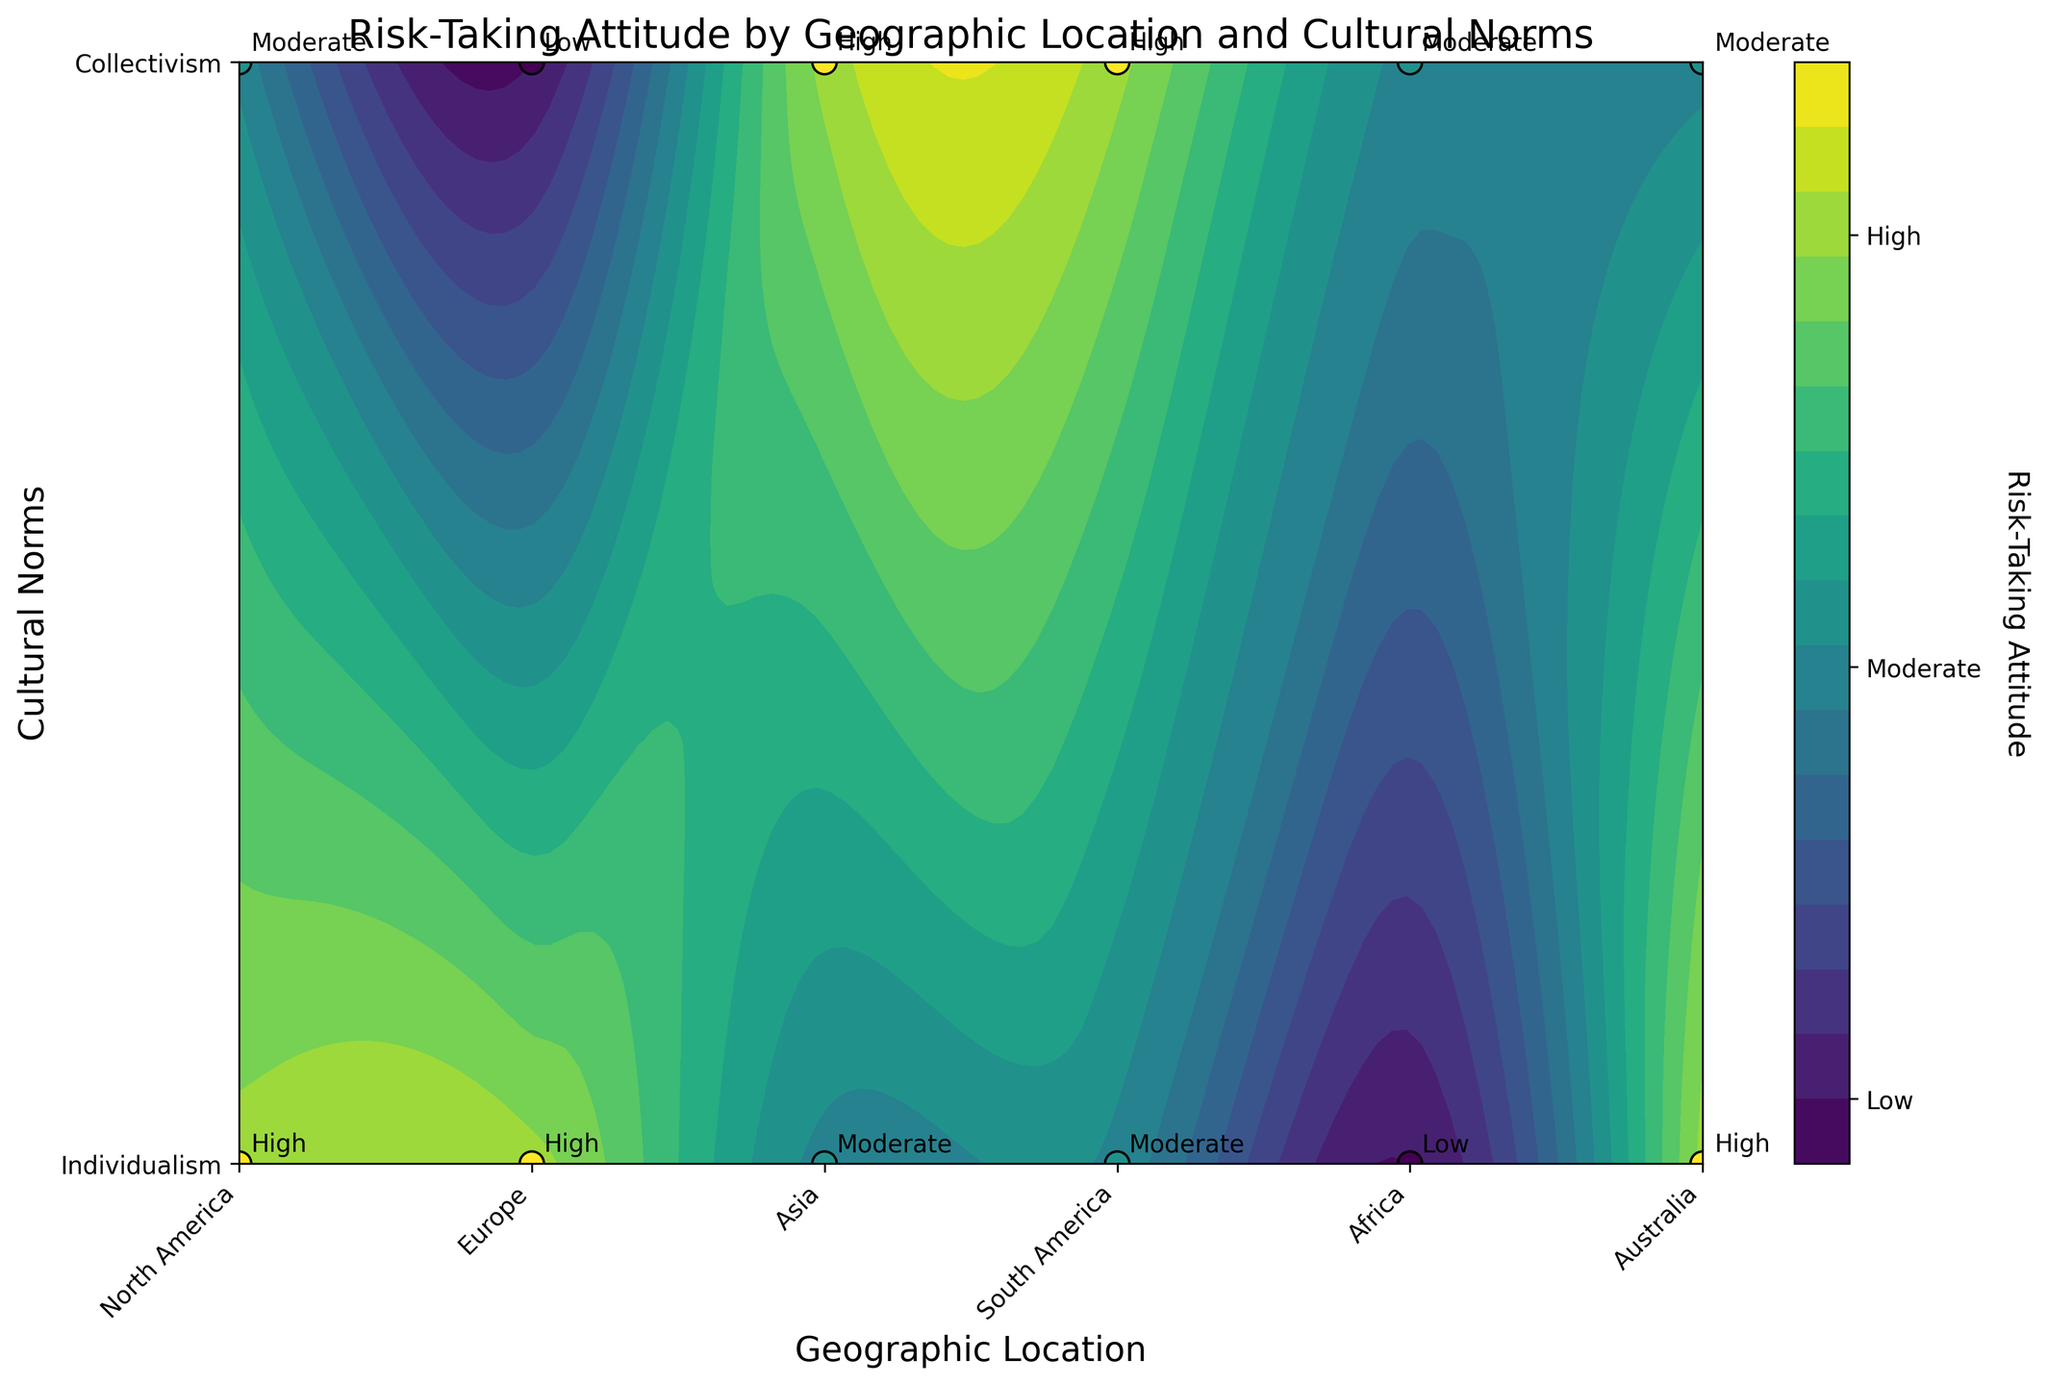What are the titles of the axes on the plot? The x-axis represents 'Geographic Location' and the y-axis represents 'Cultural Norms', as labeled in the plot.
Answer: Geographic Location, Cultural Norms What is the highest level of risk-taking attitude displayed by North America? North America has two data points: one with 'High' and the other with 'Moderate' risk-taking attitude. The highest level is 'High'.
Answer: High Which continent shows the lowest risk-taking attitude for collectivism? In the plot, Europe shows a 'Low' risk-taking attitude when cultural norms are collectivist.
Answer: Europe Between Europe and Australia, which one has a higher risk-taking attitude for individualism? Both Europe and Australia have a 'High' risk-taking attitude for individualism, hence they are equal in this respect.
Answer: Equal What is the median risk-taking attitude of all regions considering both cultural norms? First list the risk-taking attitudes converted to numeric values for all regions: [2, 1, 2, 0, 1, 2, 1, 2, 0, 1, 2, 1]. Ordered values are: [0, 0, 1, 1, 1, 1, 2, 2, 2, 2]. The median is the average of the 6th and 7th values: (1+2)/2 = 1.5.
Answer: 1.5 Which region has the most diverse risk-taking attitudes across cultural norms? Looking at the extremes, North America displays both 'High' and 'Moderate'. Other regions either stick to neighboring levels like 'Moderate' to 'High' or have more uniform attitudes.
Answer: North America 